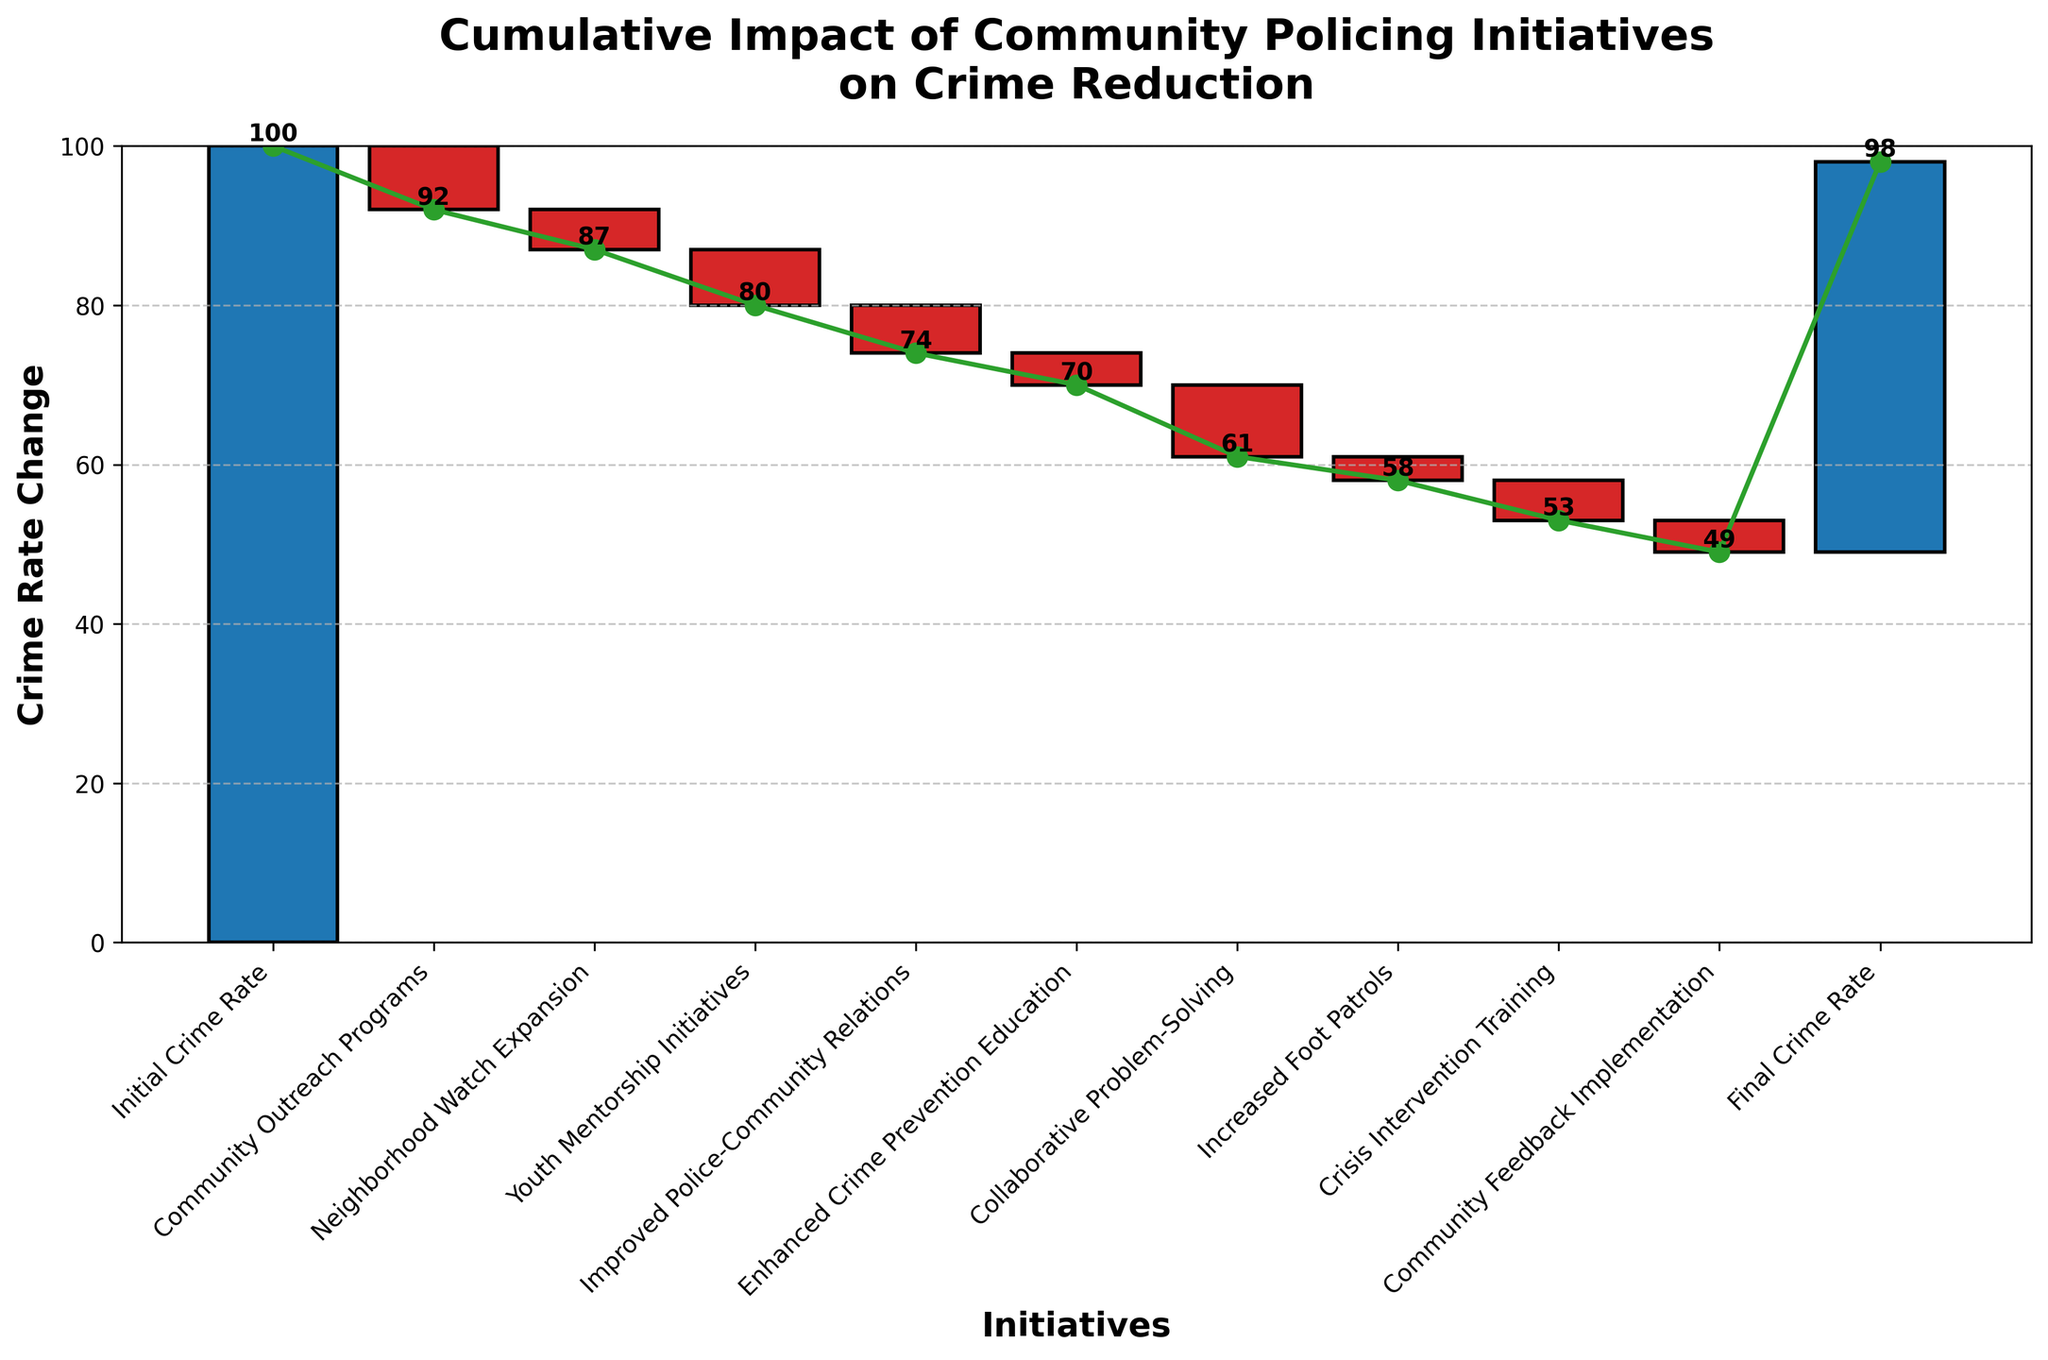What is the title of the chart? The title is the text displayed at the top of the chart. It summarizes the main focus of the chart.
Answer: Cumulative Impact of Community Policing Initiatives on Crime Reduction How many categories are displayed in the chart? Count the number of bars or labels on the x-axis of the chart. Each category should have a unique label.
Answer: 10 Which initiative had the largest impact on crime reduction? To determine the largest impact, look for the initiative with the largest negative value.
Answer: Collaborative Problem-Solving What is the final crime rate after all initiatives? The final crime rate is the last value in the cumulative sum, displayed as the last point in the cumulative line.
Answer: 49 What was the crime rate reduction after implementing the Neighborhood Watch Expansion? Look at the value associated with the Neighborhood Watch Expansion.
Answer: -5 How does the effect of Improved Police-Community Relations compare with Crisis Intervention Training? Compare the values for each of these initiatives. Improved Police-Community Relations is -6 and Crisis Intervention Training is -5.
Answer: Improved Police-Community Relations had a larger impact What is the cumulative crime rate change after Youth Mentorship Initiatives? Add up the values incrementally until the Youth Mentorship Initiatives category. The cumulative sum is displayed as a data point on the cumulative line.
Answer: -20 Considering only categories with 'Community' in their name, what is the combined reduction in crime rate? Sum the values of categories that include 'Community'. These are Community Outreach Programs and Improved Police-Community Relations. -8 + -6 = -14
Answer: 14 Which initiative had the smallest impact on crime reduction? To determine the smallest impact, look for the initiative with the least negative value or the least change.
Answer: Increased Foot Patrols By how much did the crime rate decrease cumulatively after the first three initiatives? Add up the values of the first three categories: Initial Crime Rate (-100 + 8 + 5) = -20. The Initial Crime Rate isn't included in the calculation but provides the starting point. The cumulative sum is the difference.
Answer: -20 